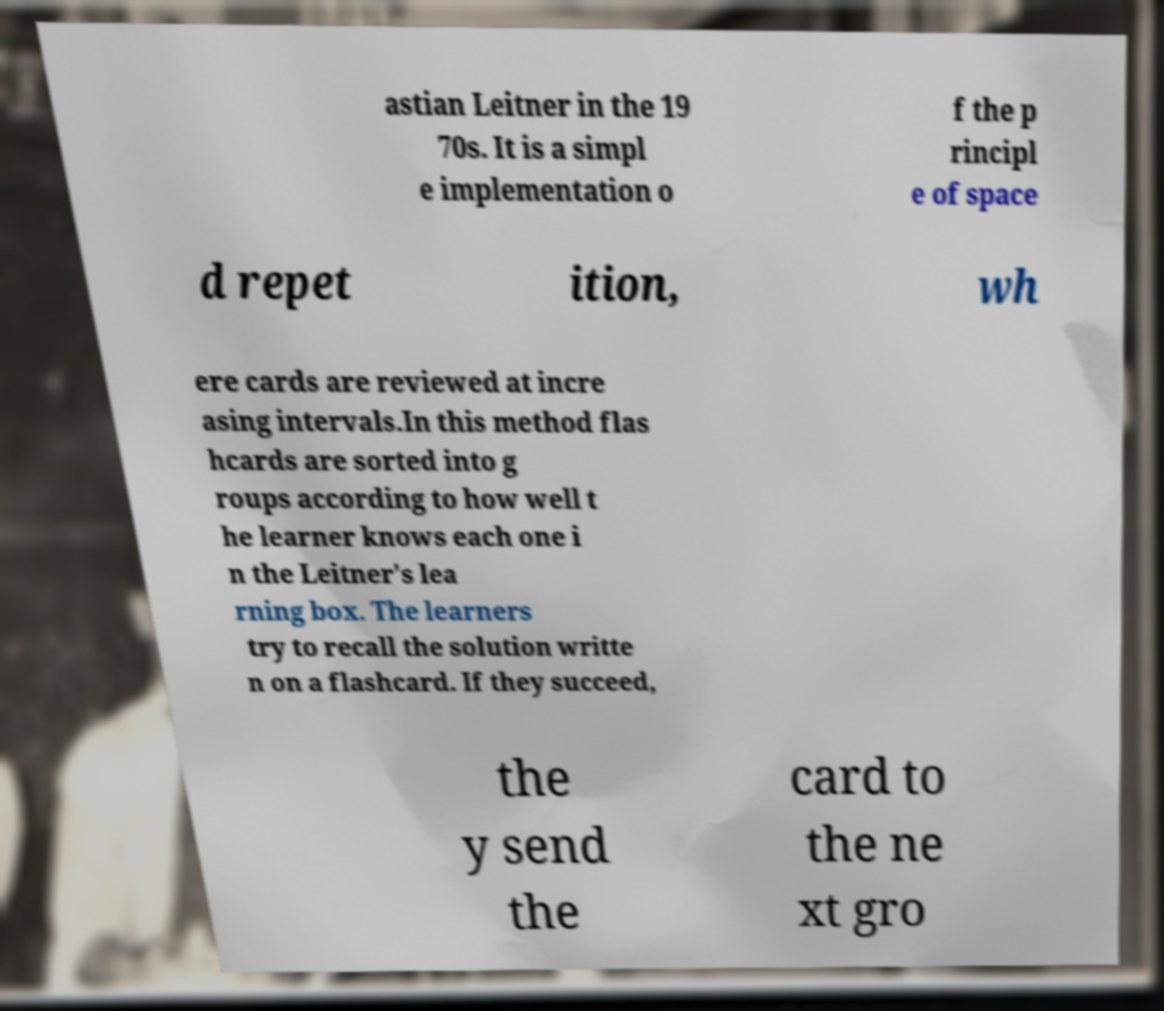Could you extract and type out the text from this image? astian Leitner in the 19 70s. It is a simpl e implementation o f the p rincipl e of space d repet ition, wh ere cards are reviewed at incre asing intervals.In this method flas hcards are sorted into g roups according to how well t he learner knows each one i n the Leitner's lea rning box. The learners try to recall the solution writte n on a flashcard. If they succeed, the y send the card to the ne xt gro 